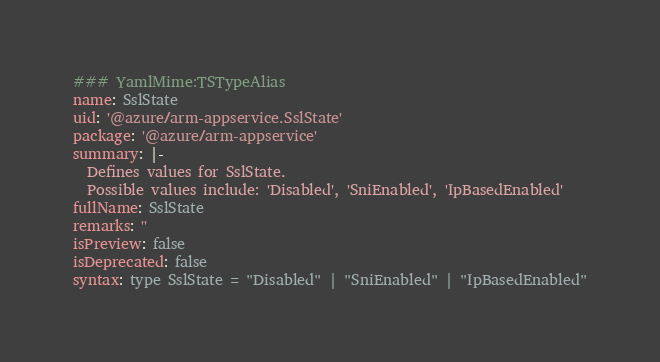<code> <loc_0><loc_0><loc_500><loc_500><_YAML_>### YamlMime:TSTypeAlias
name: SslState
uid: '@azure/arm-appservice.SslState'
package: '@azure/arm-appservice'
summary: |-
  Defines values for SslState.
  Possible values include: 'Disabled', 'SniEnabled', 'IpBasedEnabled'
fullName: SslState
remarks: ''
isPreview: false
isDeprecated: false
syntax: type SslState = "Disabled" | "SniEnabled" | "IpBasedEnabled"
</code> 